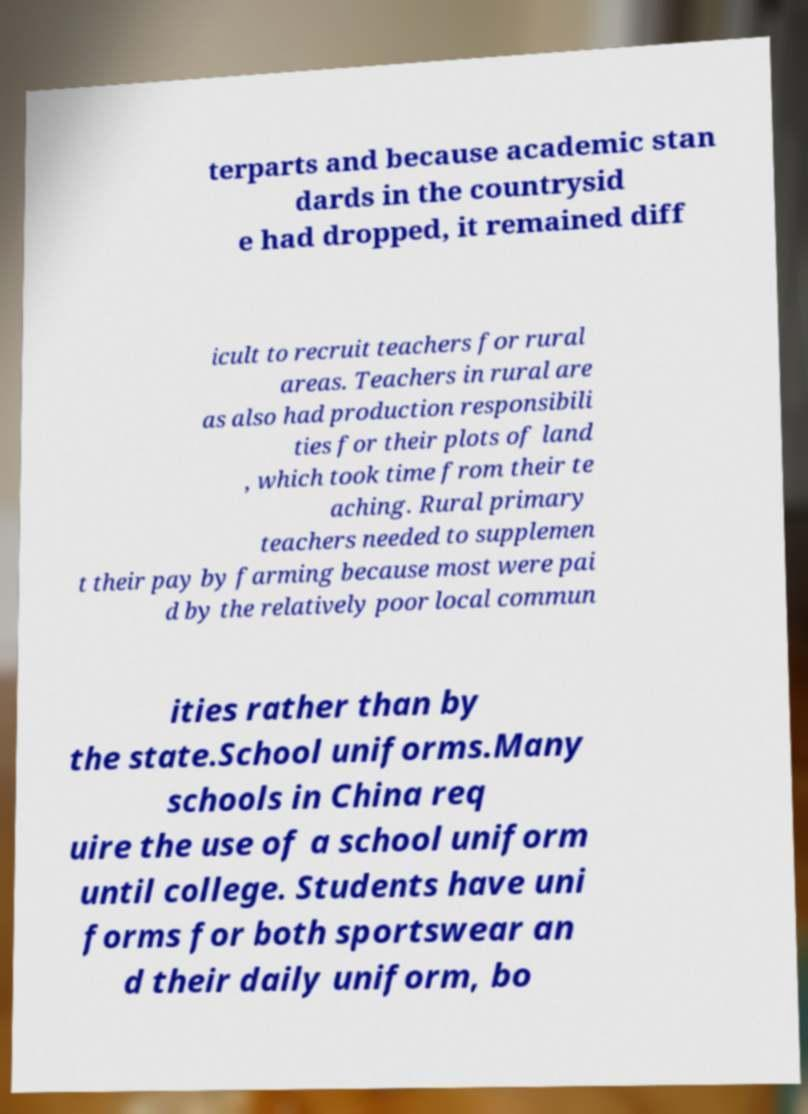Can you accurately transcribe the text from the provided image for me? terparts and because academic stan dards in the countrysid e had dropped, it remained diff icult to recruit teachers for rural areas. Teachers in rural are as also had production responsibili ties for their plots of land , which took time from their te aching. Rural primary teachers needed to supplemen t their pay by farming because most were pai d by the relatively poor local commun ities rather than by the state.School uniforms.Many schools in China req uire the use of a school uniform until college. Students have uni forms for both sportswear an d their daily uniform, bo 